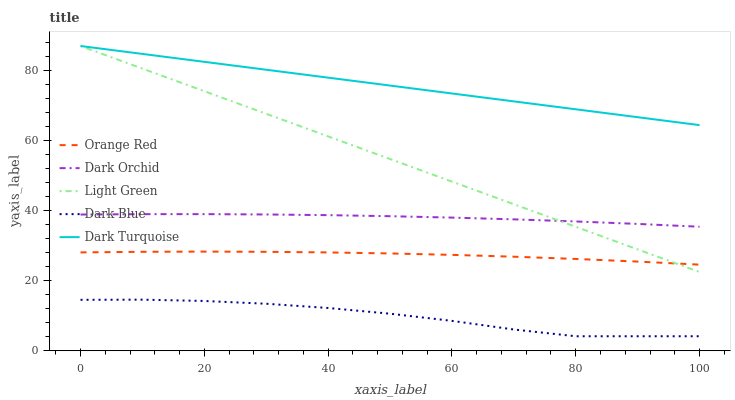Does Dark Blue have the minimum area under the curve?
Answer yes or no. Yes. Does Dark Turquoise have the maximum area under the curve?
Answer yes or no. Yes. Does Light Green have the minimum area under the curve?
Answer yes or no. No. Does Light Green have the maximum area under the curve?
Answer yes or no. No. Is Light Green the smoothest?
Answer yes or no. Yes. Is Dark Blue the roughest?
Answer yes or no. Yes. Is Orange Red the smoothest?
Answer yes or no. No. Is Orange Red the roughest?
Answer yes or no. No. Does Dark Blue have the lowest value?
Answer yes or no. Yes. Does Light Green have the lowest value?
Answer yes or no. No. Does Dark Turquoise have the highest value?
Answer yes or no. Yes. Does Orange Red have the highest value?
Answer yes or no. No. Is Dark Blue less than Dark Orchid?
Answer yes or no. Yes. Is Orange Red greater than Dark Blue?
Answer yes or no. Yes. Does Dark Orchid intersect Light Green?
Answer yes or no. Yes. Is Dark Orchid less than Light Green?
Answer yes or no. No. Is Dark Orchid greater than Light Green?
Answer yes or no. No. Does Dark Blue intersect Dark Orchid?
Answer yes or no. No. 